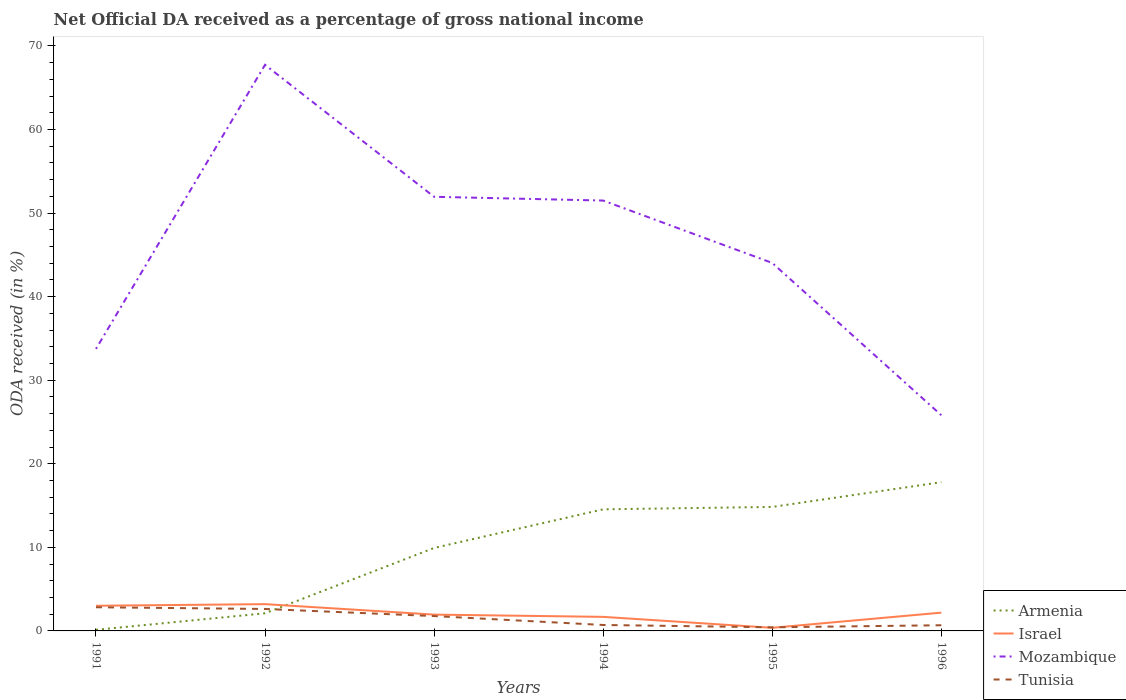Is the number of lines equal to the number of legend labels?
Keep it short and to the point. Yes. Across all years, what is the maximum net official DA received in Tunisia?
Your answer should be compact. 0.43. What is the total net official DA received in Armenia in the graph?
Your answer should be very brief. -17.66. What is the difference between the highest and the second highest net official DA received in Mozambique?
Offer a terse response. 41.92. Is the net official DA received in Israel strictly greater than the net official DA received in Mozambique over the years?
Provide a succinct answer. Yes. How many lines are there?
Ensure brevity in your answer.  4. Are the values on the major ticks of Y-axis written in scientific E-notation?
Your response must be concise. No. Where does the legend appear in the graph?
Provide a short and direct response. Bottom right. How many legend labels are there?
Your response must be concise. 4. How are the legend labels stacked?
Offer a terse response. Vertical. What is the title of the graph?
Your answer should be very brief. Net Official DA received as a percentage of gross national income. What is the label or title of the X-axis?
Your answer should be very brief. Years. What is the label or title of the Y-axis?
Provide a short and direct response. ODA received (in %). What is the ODA received (in %) in Armenia in 1991?
Make the answer very short. 0.13. What is the ODA received (in %) of Israel in 1991?
Offer a very short reply. 3.01. What is the ODA received (in %) of Mozambique in 1991?
Your answer should be very brief. 33.75. What is the ODA received (in %) in Tunisia in 1991?
Offer a terse response. 2.83. What is the ODA received (in %) of Armenia in 1992?
Your answer should be very brief. 2.11. What is the ODA received (in %) of Israel in 1992?
Your response must be concise. 3.2. What is the ODA received (in %) of Mozambique in 1992?
Your answer should be very brief. 67.74. What is the ODA received (in %) of Tunisia in 1992?
Your response must be concise. 2.63. What is the ODA received (in %) of Armenia in 1993?
Make the answer very short. 9.93. What is the ODA received (in %) of Israel in 1993?
Ensure brevity in your answer.  1.95. What is the ODA received (in %) of Mozambique in 1993?
Offer a terse response. 51.95. What is the ODA received (in %) in Tunisia in 1993?
Make the answer very short. 1.78. What is the ODA received (in %) of Armenia in 1994?
Give a very brief answer. 14.55. What is the ODA received (in %) of Israel in 1994?
Give a very brief answer. 1.68. What is the ODA received (in %) of Mozambique in 1994?
Offer a very short reply. 51.49. What is the ODA received (in %) of Tunisia in 1994?
Offer a very short reply. 0.71. What is the ODA received (in %) of Armenia in 1995?
Ensure brevity in your answer.  14.84. What is the ODA received (in %) of Israel in 1995?
Your answer should be very brief. 0.37. What is the ODA received (in %) of Mozambique in 1995?
Your response must be concise. 44.03. What is the ODA received (in %) in Tunisia in 1995?
Make the answer very short. 0.43. What is the ODA received (in %) in Armenia in 1996?
Provide a short and direct response. 17.8. What is the ODA received (in %) of Israel in 1996?
Offer a very short reply. 2.19. What is the ODA received (in %) in Mozambique in 1996?
Ensure brevity in your answer.  25.81. What is the ODA received (in %) of Tunisia in 1996?
Give a very brief answer. 0.68. Across all years, what is the maximum ODA received (in %) of Armenia?
Keep it short and to the point. 17.8. Across all years, what is the maximum ODA received (in %) of Israel?
Give a very brief answer. 3.2. Across all years, what is the maximum ODA received (in %) of Mozambique?
Your answer should be compact. 67.74. Across all years, what is the maximum ODA received (in %) in Tunisia?
Offer a terse response. 2.83. Across all years, what is the minimum ODA received (in %) of Armenia?
Give a very brief answer. 0.13. Across all years, what is the minimum ODA received (in %) in Israel?
Make the answer very short. 0.37. Across all years, what is the minimum ODA received (in %) in Mozambique?
Offer a very short reply. 25.81. Across all years, what is the minimum ODA received (in %) in Tunisia?
Your answer should be very brief. 0.43. What is the total ODA received (in %) of Armenia in the graph?
Your response must be concise. 59.35. What is the total ODA received (in %) in Israel in the graph?
Provide a succinct answer. 12.41. What is the total ODA received (in %) of Mozambique in the graph?
Make the answer very short. 274.76. What is the total ODA received (in %) of Tunisia in the graph?
Your answer should be compact. 9.06. What is the difference between the ODA received (in %) of Armenia in 1991 and that in 1992?
Make the answer very short. -1.98. What is the difference between the ODA received (in %) in Israel in 1991 and that in 1992?
Your answer should be compact. -0.19. What is the difference between the ODA received (in %) in Mozambique in 1991 and that in 1992?
Your response must be concise. -33.99. What is the difference between the ODA received (in %) in Tunisia in 1991 and that in 1992?
Provide a succinct answer. 0.2. What is the difference between the ODA received (in %) of Armenia in 1991 and that in 1993?
Your answer should be very brief. -9.8. What is the difference between the ODA received (in %) of Israel in 1991 and that in 1993?
Your answer should be compact. 1.06. What is the difference between the ODA received (in %) in Mozambique in 1991 and that in 1993?
Your answer should be very brief. -18.2. What is the difference between the ODA received (in %) in Tunisia in 1991 and that in 1993?
Your response must be concise. 1.05. What is the difference between the ODA received (in %) of Armenia in 1991 and that in 1994?
Your response must be concise. -14.42. What is the difference between the ODA received (in %) of Israel in 1991 and that in 1994?
Ensure brevity in your answer.  1.33. What is the difference between the ODA received (in %) of Mozambique in 1991 and that in 1994?
Keep it short and to the point. -17.75. What is the difference between the ODA received (in %) in Tunisia in 1991 and that in 1994?
Your response must be concise. 2.12. What is the difference between the ODA received (in %) in Armenia in 1991 and that in 1995?
Ensure brevity in your answer.  -14.71. What is the difference between the ODA received (in %) of Israel in 1991 and that in 1995?
Ensure brevity in your answer.  2.64. What is the difference between the ODA received (in %) in Mozambique in 1991 and that in 1995?
Provide a short and direct response. -10.28. What is the difference between the ODA received (in %) of Tunisia in 1991 and that in 1995?
Give a very brief answer. 2.4. What is the difference between the ODA received (in %) of Armenia in 1991 and that in 1996?
Ensure brevity in your answer.  -17.66. What is the difference between the ODA received (in %) in Israel in 1991 and that in 1996?
Offer a very short reply. 0.82. What is the difference between the ODA received (in %) of Mozambique in 1991 and that in 1996?
Provide a succinct answer. 7.93. What is the difference between the ODA received (in %) in Tunisia in 1991 and that in 1996?
Keep it short and to the point. 2.15. What is the difference between the ODA received (in %) of Armenia in 1992 and that in 1993?
Give a very brief answer. -7.82. What is the difference between the ODA received (in %) in Israel in 1992 and that in 1993?
Your answer should be very brief. 1.25. What is the difference between the ODA received (in %) in Mozambique in 1992 and that in 1993?
Your response must be concise. 15.79. What is the difference between the ODA received (in %) in Tunisia in 1992 and that in 1993?
Your answer should be very brief. 0.85. What is the difference between the ODA received (in %) in Armenia in 1992 and that in 1994?
Your response must be concise. -12.44. What is the difference between the ODA received (in %) in Israel in 1992 and that in 1994?
Make the answer very short. 1.52. What is the difference between the ODA received (in %) in Mozambique in 1992 and that in 1994?
Your answer should be very brief. 16.24. What is the difference between the ODA received (in %) of Tunisia in 1992 and that in 1994?
Ensure brevity in your answer.  1.92. What is the difference between the ODA received (in %) in Armenia in 1992 and that in 1995?
Your answer should be very brief. -12.73. What is the difference between the ODA received (in %) of Israel in 1992 and that in 1995?
Your answer should be very brief. 2.83. What is the difference between the ODA received (in %) of Mozambique in 1992 and that in 1995?
Keep it short and to the point. 23.7. What is the difference between the ODA received (in %) of Tunisia in 1992 and that in 1995?
Keep it short and to the point. 2.19. What is the difference between the ODA received (in %) of Armenia in 1992 and that in 1996?
Keep it short and to the point. -15.69. What is the difference between the ODA received (in %) of Israel in 1992 and that in 1996?
Make the answer very short. 1.02. What is the difference between the ODA received (in %) of Mozambique in 1992 and that in 1996?
Offer a very short reply. 41.92. What is the difference between the ODA received (in %) in Tunisia in 1992 and that in 1996?
Your answer should be very brief. 1.95. What is the difference between the ODA received (in %) of Armenia in 1993 and that in 1994?
Keep it short and to the point. -4.62. What is the difference between the ODA received (in %) of Israel in 1993 and that in 1994?
Provide a short and direct response. 0.27. What is the difference between the ODA received (in %) of Mozambique in 1993 and that in 1994?
Give a very brief answer. 0.45. What is the difference between the ODA received (in %) in Tunisia in 1993 and that in 1994?
Offer a terse response. 1.07. What is the difference between the ODA received (in %) of Armenia in 1993 and that in 1995?
Provide a succinct answer. -4.91. What is the difference between the ODA received (in %) of Israel in 1993 and that in 1995?
Your response must be concise. 1.58. What is the difference between the ODA received (in %) in Mozambique in 1993 and that in 1995?
Offer a very short reply. 7.91. What is the difference between the ODA received (in %) in Tunisia in 1993 and that in 1995?
Offer a very short reply. 1.34. What is the difference between the ODA received (in %) in Armenia in 1993 and that in 1996?
Keep it short and to the point. -7.87. What is the difference between the ODA received (in %) of Israel in 1993 and that in 1996?
Provide a succinct answer. -0.24. What is the difference between the ODA received (in %) in Mozambique in 1993 and that in 1996?
Your answer should be compact. 26.13. What is the difference between the ODA received (in %) in Tunisia in 1993 and that in 1996?
Offer a terse response. 1.1. What is the difference between the ODA received (in %) in Armenia in 1994 and that in 1995?
Offer a terse response. -0.29. What is the difference between the ODA received (in %) of Israel in 1994 and that in 1995?
Offer a very short reply. 1.31. What is the difference between the ODA received (in %) of Mozambique in 1994 and that in 1995?
Keep it short and to the point. 7.46. What is the difference between the ODA received (in %) of Tunisia in 1994 and that in 1995?
Your answer should be very brief. 0.28. What is the difference between the ODA received (in %) in Armenia in 1994 and that in 1996?
Offer a very short reply. -3.25. What is the difference between the ODA received (in %) of Israel in 1994 and that in 1996?
Your response must be concise. -0.51. What is the difference between the ODA received (in %) in Mozambique in 1994 and that in 1996?
Provide a short and direct response. 25.68. What is the difference between the ODA received (in %) in Tunisia in 1994 and that in 1996?
Your answer should be very brief. 0.03. What is the difference between the ODA received (in %) in Armenia in 1995 and that in 1996?
Your answer should be compact. -2.96. What is the difference between the ODA received (in %) in Israel in 1995 and that in 1996?
Make the answer very short. -1.81. What is the difference between the ODA received (in %) in Mozambique in 1995 and that in 1996?
Provide a short and direct response. 18.22. What is the difference between the ODA received (in %) of Tunisia in 1995 and that in 1996?
Provide a short and direct response. -0.25. What is the difference between the ODA received (in %) of Armenia in 1991 and the ODA received (in %) of Israel in 1992?
Offer a very short reply. -3.07. What is the difference between the ODA received (in %) of Armenia in 1991 and the ODA received (in %) of Mozambique in 1992?
Offer a terse response. -67.6. What is the difference between the ODA received (in %) in Armenia in 1991 and the ODA received (in %) in Tunisia in 1992?
Make the answer very short. -2.5. What is the difference between the ODA received (in %) in Israel in 1991 and the ODA received (in %) in Mozambique in 1992?
Offer a terse response. -64.72. What is the difference between the ODA received (in %) of Israel in 1991 and the ODA received (in %) of Tunisia in 1992?
Your response must be concise. 0.39. What is the difference between the ODA received (in %) in Mozambique in 1991 and the ODA received (in %) in Tunisia in 1992?
Give a very brief answer. 31.12. What is the difference between the ODA received (in %) in Armenia in 1991 and the ODA received (in %) in Israel in 1993?
Ensure brevity in your answer.  -1.82. What is the difference between the ODA received (in %) of Armenia in 1991 and the ODA received (in %) of Mozambique in 1993?
Make the answer very short. -51.81. What is the difference between the ODA received (in %) in Armenia in 1991 and the ODA received (in %) in Tunisia in 1993?
Your response must be concise. -1.65. What is the difference between the ODA received (in %) of Israel in 1991 and the ODA received (in %) of Mozambique in 1993?
Offer a very short reply. -48.93. What is the difference between the ODA received (in %) in Israel in 1991 and the ODA received (in %) in Tunisia in 1993?
Make the answer very short. 1.24. What is the difference between the ODA received (in %) of Mozambique in 1991 and the ODA received (in %) of Tunisia in 1993?
Keep it short and to the point. 31.97. What is the difference between the ODA received (in %) of Armenia in 1991 and the ODA received (in %) of Israel in 1994?
Offer a terse response. -1.55. What is the difference between the ODA received (in %) of Armenia in 1991 and the ODA received (in %) of Mozambique in 1994?
Make the answer very short. -51.36. What is the difference between the ODA received (in %) of Armenia in 1991 and the ODA received (in %) of Tunisia in 1994?
Offer a terse response. -0.58. What is the difference between the ODA received (in %) of Israel in 1991 and the ODA received (in %) of Mozambique in 1994?
Your answer should be compact. -48.48. What is the difference between the ODA received (in %) in Israel in 1991 and the ODA received (in %) in Tunisia in 1994?
Provide a short and direct response. 2.3. What is the difference between the ODA received (in %) in Mozambique in 1991 and the ODA received (in %) in Tunisia in 1994?
Your answer should be compact. 33.04. What is the difference between the ODA received (in %) of Armenia in 1991 and the ODA received (in %) of Israel in 1995?
Ensure brevity in your answer.  -0.24. What is the difference between the ODA received (in %) of Armenia in 1991 and the ODA received (in %) of Mozambique in 1995?
Provide a short and direct response. -43.9. What is the difference between the ODA received (in %) of Armenia in 1991 and the ODA received (in %) of Tunisia in 1995?
Your answer should be compact. -0.3. What is the difference between the ODA received (in %) of Israel in 1991 and the ODA received (in %) of Mozambique in 1995?
Offer a terse response. -41.02. What is the difference between the ODA received (in %) of Israel in 1991 and the ODA received (in %) of Tunisia in 1995?
Ensure brevity in your answer.  2.58. What is the difference between the ODA received (in %) of Mozambique in 1991 and the ODA received (in %) of Tunisia in 1995?
Make the answer very short. 33.31. What is the difference between the ODA received (in %) in Armenia in 1991 and the ODA received (in %) in Israel in 1996?
Provide a succinct answer. -2.06. What is the difference between the ODA received (in %) in Armenia in 1991 and the ODA received (in %) in Mozambique in 1996?
Offer a terse response. -25.68. What is the difference between the ODA received (in %) of Armenia in 1991 and the ODA received (in %) of Tunisia in 1996?
Your response must be concise. -0.55. What is the difference between the ODA received (in %) of Israel in 1991 and the ODA received (in %) of Mozambique in 1996?
Keep it short and to the point. -22.8. What is the difference between the ODA received (in %) in Israel in 1991 and the ODA received (in %) in Tunisia in 1996?
Give a very brief answer. 2.33. What is the difference between the ODA received (in %) in Mozambique in 1991 and the ODA received (in %) in Tunisia in 1996?
Provide a short and direct response. 33.07. What is the difference between the ODA received (in %) of Armenia in 1992 and the ODA received (in %) of Israel in 1993?
Make the answer very short. 0.16. What is the difference between the ODA received (in %) of Armenia in 1992 and the ODA received (in %) of Mozambique in 1993?
Give a very brief answer. -49.83. What is the difference between the ODA received (in %) in Armenia in 1992 and the ODA received (in %) in Tunisia in 1993?
Keep it short and to the point. 0.33. What is the difference between the ODA received (in %) of Israel in 1992 and the ODA received (in %) of Mozambique in 1993?
Keep it short and to the point. -48.74. What is the difference between the ODA received (in %) of Israel in 1992 and the ODA received (in %) of Tunisia in 1993?
Give a very brief answer. 1.43. What is the difference between the ODA received (in %) of Mozambique in 1992 and the ODA received (in %) of Tunisia in 1993?
Your answer should be compact. 65.96. What is the difference between the ODA received (in %) in Armenia in 1992 and the ODA received (in %) in Israel in 1994?
Your response must be concise. 0.43. What is the difference between the ODA received (in %) of Armenia in 1992 and the ODA received (in %) of Mozambique in 1994?
Give a very brief answer. -49.38. What is the difference between the ODA received (in %) of Armenia in 1992 and the ODA received (in %) of Tunisia in 1994?
Give a very brief answer. 1.4. What is the difference between the ODA received (in %) of Israel in 1992 and the ODA received (in %) of Mozambique in 1994?
Your answer should be compact. -48.29. What is the difference between the ODA received (in %) in Israel in 1992 and the ODA received (in %) in Tunisia in 1994?
Provide a short and direct response. 2.49. What is the difference between the ODA received (in %) in Mozambique in 1992 and the ODA received (in %) in Tunisia in 1994?
Your response must be concise. 67.02. What is the difference between the ODA received (in %) in Armenia in 1992 and the ODA received (in %) in Israel in 1995?
Your response must be concise. 1.74. What is the difference between the ODA received (in %) in Armenia in 1992 and the ODA received (in %) in Mozambique in 1995?
Your response must be concise. -41.92. What is the difference between the ODA received (in %) in Armenia in 1992 and the ODA received (in %) in Tunisia in 1995?
Offer a very short reply. 1.68. What is the difference between the ODA received (in %) of Israel in 1992 and the ODA received (in %) of Mozambique in 1995?
Your response must be concise. -40.83. What is the difference between the ODA received (in %) in Israel in 1992 and the ODA received (in %) in Tunisia in 1995?
Ensure brevity in your answer.  2.77. What is the difference between the ODA received (in %) of Mozambique in 1992 and the ODA received (in %) of Tunisia in 1995?
Keep it short and to the point. 67.3. What is the difference between the ODA received (in %) of Armenia in 1992 and the ODA received (in %) of Israel in 1996?
Provide a succinct answer. -0.08. What is the difference between the ODA received (in %) of Armenia in 1992 and the ODA received (in %) of Mozambique in 1996?
Ensure brevity in your answer.  -23.7. What is the difference between the ODA received (in %) of Armenia in 1992 and the ODA received (in %) of Tunisia in 1996?
Keep it short and to the point. 1.43. What is the difference between the ODA received (in %) in Israel in 1992 and the ODA received (in %) in Mozambique in 1996?
Your answer should be very brief. -22.61. What is the difference between the ODA received (in %) of Israel in 1992 and the ODA received (in %) of Tunisia in 1996?
Provide a succinct answer. 2.53. What is the difference between the ODA received (in %) of Mozambique in 1992 and the ODA received (in %) of Tunisia in 1996?
Provide a succinct answer. 67.06. What is the difference between the ODA received (in %) of Armenia in 1993 and the ODA received (in %) of Israel in 1994?
Your answer should be compact. 8.25. What is the difference between the ODA received (in %) in Armenia in 1993 and the ODA received (in %) in Mozambique in 1994?
Keep it short and to the point. -41.57. What is the difference between the ODA received (in %) in Armenia in 1993 and the ODA received (in %) in Tunisia in 1994?
Your answer should be compact. 9.22. What is the difference between the ODA received (in %) of Israel in 1993 and the ODA received (in %) of Mozambique in 1994?
Your answer should be very brief. -49.54. What is the difference between the ODA received (in %) of Israel in 1993 and the ODA received (in %) of Tunisia in 1994?
Provide a short and direct response. 1.24. What is the difference between the ODA received (in %) in Mozambique in 1993 and the ODA received (in %) in Tunisia in 1994?
Ensure brevity in your answer.  51.23. What is the difference between the ODA received (in %) of Armenia in 1993 and the ODA received (in %) of Israel in 1995?
Make the answer very short. 9.55. What is the difference between the ODA received (in %) in Armenia in 1993 and the ODA received (in %) in Mozambique in 1995?
Provide a succinct answer. -34.1. What is the difference between the ODA received (in %) of Armenia in 1993 and the ODA received (in %) of Tunisia in 1995?
Your response must be concise. 9.49. What is the difference between the ODA received (in %) of Israel in 1993 and the ODA received (in %) of Mozambique in 1995?
Your answer should be very brief. -42.08. What is the difference between the ODA received (in %) of Israel in 1993 and the ODA received (in %) of Tunisia in 1995?
Give a very brief answer. 1.52. What is the difference between the ODA received (in %) in Mozambique in 1993 and the ODA received (in %) in Tunisia in 1995?
Provide a short and direct response. 51.51. What is the difference between the ODA received (in %) of Armenia in 1993 and the ODA received (in %) of Israel in 1996?
Make the answer very short. 7.74. What is the difference between the ODA received (in %) in Armenia in 1993 and the ODA received (in %) in Mozambique in 1996?
Give a very brief answer. -15.88. What is the difference between the ODA received (in %) of Armenia in 1993 and the ODA received (in %) of Tunisia in 1996?
Your answer should be very brief. 9.25. What is the difference between the ODA received (in %) in Israel in 1993 and the ODA received (in %) in Mozambique in 1996?
Your answer should be compact. -23.86. What is the difference between the ODA received (in %) of Israel in 1993 and the ODA received (in %) of Tunisia in 1996?
Make the answer very short. 1.27. What is the difference between the ODA received (in %) of Mozambique in 1993 and the ODA received (in %) of Tunisia in 1996?
Ensure brevity in your answer.  51.27. What is the difference between the ODA received (in %) of Armenia in 1994 and the ODA received (in %) of Israel in 1995?
Offer a terse response. 14.18. What is the difference between the ODA received (in %) of Armenia in 1994 and the ODA received (in %) of Mozambique in 1995?
Your answer should be compact. -29.48. What is the difference between the ODA received (in %) in Armenia in 1994 and the ODA received (in %) in Tunisia in 1995?
Your answer should be compact. 14.12. What is the difference between the ODA received (in %) in Israel in 1994 and the ODA received (in %) in Mozambique in 1995?
Your response must be concise. -42.35. What is the difference between the ODA received (in %) of Israel in 1994 and the ODA received (in %) of Tunisia in 1995?
Offer a very short reply. 1.25. What is the difference between the ODA received (in %) in Mozambique in 1994 and the ODA received (in %) in Tunisia in 1995?
Provide a succinct answer. 51.06. What is the difference between the ODA received (in %) of Armenia in 1994 and the ODA received (in %) of Israel in 1996?
Give a very brief answer. 12.36. What is the difference between the ODA received (in %) in Armenia in 1994 and the ODA received (in %) in Mozambique in 1996?
Your answer should be compact. -11.26. What is the difference between the ODA received (in %) of Armenia in 1994 and the ODA received (in %) of Tunisia in 1996?
Provide a succinct answer. 13.87. What is the difference between the ODA received (in %) in Israel in 1994 and the ODA received (in %) in Mozambique in 1996?
Offer a very short reply. -24.13. What is the difference between the ODA received (in %) in Mozambique in 1994 and the ODA received (in %) in Tunisia in 1996?
Your answer should be compact. 50.82. What is the difference between the ODA received (in %) of Armenia in 1995 and the ODA received (in %) of Israel in 1996?
Ensure brevity in your answer.  12.65. What is the difference between the ODA received (in %) of Armenia in 1995 and the ODA received (in %) of Mozambique in 1996?
Make the answer very short. -10.97. What is the difference between the ODA received (in %) in Armenia in 1995 and the ODA received (in %) in Tunisia in 1996?
Provide a succinct answer. 14.16. What is the difference between the ODA received (in %) in Israel in 1995 and the ODA received (in %) in Mozambique in 1996?
Ensure brevity in your answer.  -25.44. What is the difference between the ODA received (in %) in Israel in 1995 and the ODA received (in %) in Tunisia in 1996?
Keep it short and to the point. -0.31. What is the difference between the ODA received (in %) in Mozambique in 1995 and the ODA received (in %) in Tunisia in 1996?
Offer a very short reply. 43.35. What is the average ODA received (in %) in Armenia per year?
Provide a succinct answer. 9.89. What is the average ODA received (in %) of Israel per year?
Your answer should be very brief. 2.07. What is the average ODA received (in %) in Mozambique per year?
Offer a terse response. 45.79. What is the average ODA received (in %) in Tunisia per year?
Offer a very short reply. 1.51. In the year 1991, what is the difference between the ODA received (in %) in Armenia and ODA received (in %) in Israel?
Your answer should be compact. -2.88. In the year 1991, what is the difference between the ODA received (in %) in Armenia and ODA received (in %) in Mozambique?
Offer a very short reply. -33.62. In the year 1991, what is the difference between the ODA received (in %) in Armenia and ODA received (in %) in Tunisia?
Provide a short and direct response. -2.7. In the year 1991, what is the difference between the ODA received (in %) of Israel and ODA received (in %) of Mozambique?
Give a very brief answer. -30.73. In the year 1991, what is the difference between the ODA received (in %) of Israel and ODA received (in %) of Tunisia?
Offer a terse response. 0.18. In the year 1991, what is the difference between the ODA received (in %) in Mozambique and ODA received (in %) in Tunisia?
Ensure brevity in your answer.  30.92. In the year 1992, what is the difference between the ODA received (in %) of Armenia and ODA received (in %) of Israel?
Make the answer very short. -1.09. In the year 1992, what is the difference between the ODA received (in %) of Armenia and ODA received (in %) of Mozambique?
Make the answer very short. -65.62. In the year 1992, what is the difference between the ODA received (in %) in Armenia and ODA received (in %) in Tunisia?
Offer a terse response. -0.52. In the year 1992, what is the difference between the ODA received (in %) of Israel and ODA received (in %) of Mozambique?
Your answer should be compact. -64.53. In the year 1992, what is the difference between the ODA received (in %) in Israel and ODA received (in %) in Tunisia?
Your response must be concise. 0.58. In the year 1992, what is the difference between the ODA received (in %) of Mozambique and ODA received (in %) of Tunisia?
Make the answer very short. 65.11. In the year 1993, what is the difference between the ODA received (in %) in Armenia and ODA received (in %) in Israel?
Your answer should be very brief. 7.98. In the year 1993, what is the difference between the ODA received (in %) of Armenia and ODA received (in %) of Mozambique?
Provide a succinct answer. -42.02. In the year 1993, what is the difference between the ODA received (in %) in Armenia and ODA received (in %) in Tunisia?
Ensure brevity in your answer.  8.15. In the year 1993, what is the difference between the ODA received (in %) in Israel and ODA received (in %) in Mozambique?
Your response must be concise. -49.99. In the year 1993, what is the difference between the ODA received (in %) of Israel and ODA received (in %) of Tunisia?
Provide a short and direct response. 0.17. In the year 1993, what is the difference between the ODA received (in %) in Mozambique and ODA received (in %) in Tunisia?
Your response must be concise. 50.17. In the year 1994, what is the difference between the ODA received (in %) in Armenia and ODA received (in %) in Israel?
Provide a succinct answer. 12.87. In the year 1994, what is the difference between the ODA received (in %) in Armenia and ODA received (in %) in Mozambique?
Provide a short and direct response. -36.95. In the year 1994, what is the difference between the ODA received (in %) in Armenia and ODA received (in %) in Tunisia?
Give a very brief answer. 13.84. In the year 1994, what is the difference between the ODA received (in %) of Israel and ODA received (in %) of Mozambique?
Your response must be concise. -49.81. In the year 1994, what is the difference between the ODA received (in %) in Israel and ODA received (in %) in Tunisia?
Provide a short and direct response. 0.97. In the year 1994, what is the difference between the ODA received (in %) of Mozambique and ODA received (in %) of Tunisia?
Give a very brief answer. 50.78. In the year 1995, what is the difference between the ODA received (in %) of Armenia and ODA received (in %) of Israel?
Provide a short and direct response. 14.46. In the year 1995, what is the difference between the ODA received (in %) in Armenia and ODA received (in %) in Mozambique?
Your answer should be compact. -29.19. In the year 1995, what is the difference between the ODA received (in %) of Armenia and ODA received (in %) of Tunisia?
Your answer should be compact. 14.4. In the year 1995, what is the difference between the ODA received (in %) of Israel and ODA received (in %) of Mozambique?
Offer a very short reply. -43.66. In the year 1995, what is the difference between the ODA received (in %) of Israel and ODA received (in %) of Tunisia?
Provide a succinct answer. -0.06. In the year 1995, what is the difference between the ODA received (in %) of Mozambique and ODA received (in %) of Tunisia?
Keep it short and to the point. 43.6. In the year 1996, what is the difference between the ODA received (in %) of Armenia and ODA received (in %) of Israel?
Ensure brevity in your answer.  15.61. In the year 1996, what is the difference between the ODA received (in %) of Armenia and ODA received (in %) of Mozambique?
Keep it short and to the point. -8.02. In the year 1996, what is the difference between the ODA received (in %) in Armenia and ODA received (in %) in Tunisia?
Make the answer very short. 17.12. In the year 1996, what is the difference between the ODA received (in %) of Israel and ODA received (in %) of Mozambique?
Provide a succinct answer. -23.62. In the year 1996, what is the difference between the ODA received (in %) in Israel and ODA received (in %) in Tunisia?
Ensure brevity in your answer.  1.51. In the year 1996, what is the difference between the ODA received (in %) of Mozambique and ODA received (in %) of Tunisia?
Your answer should be compact. 25.13. What is the ratio of the ODA received (in %) of Armenia in 1991 to that in 1992?
Keep it short and to the point. 0.06. What is the ratio of the ODA received (in %) in Israel in 1991 to that in 1992?
Ensure brevity in your answer.  0.94. What is the ratio of the ODA received (in %) in Mozambique in 1991 to that in 1992?
Ensure brevity in your answer.  0.5. What is the ratio of the ODA received (in %) in Tunisia in 1991 to that in 1992?
Offer a very short reply. 1.08. What is the ratio of the ODA received (in %) in Armenia in 1991 to that in 1993?
Make the answer very short. 0.01. What is the ratio of the ODA received (in %) of Israel in 1991 to that in 1993?
Make the answer very short. 1.54. What is the ratio of the ODA received (in %) of Mozambique in 1991 to that in 1993?
Keep it short and to the point. 0.65. What is the ratio of the ODA received (in %) of Tunisia in 1991 to that in 1993?
Keep it short and to the point. 1.59. What is the ratio of the ODA received (in %) in Armenia in 1991 to that in 1994?
Your response must be concise. 0.01. What is the ratio of the ODA received (in %) in Israel in 1991 to that in 1994?
Give a very brief answer. 1.79. What is the ratio of the ODA received (in %) of Mozambique in 1991 to that in 1994?
Offer a very short reply. 0.66. What is the ratio of the ODA received (in %) in Tunisia in 1991 to that in 1994?
Your response must be concise. 3.98. What is the ratio of the ODA received (in %) in Armenia in 1991 to that in 1995?
Your answer should be very brief. 0.01. What is the ratio of the ODA received (in %) in Israel in 1991 to that in 1995?
Offer a terse response. 8.08. What is the ratio of the ODA received (in %) of Mozambique in 1991 to that in 1995?
Your answer should be very brief. 0.77. What is the ratio of the ODA received (in %) of Tunisia in 1991 to that in 1995?
Your response must be concise. 6.54. What is the ratio of the ODA received (in %) in Armenia in 1991 to that in 1996?
Provide a short and direct response. 0.01. What is the ratio of the ODA received (in %) of Israel in 1991 to that in 1996?
Offer a very short reply. 1.38. What is the ratio of the ODA received (in %) of Mozambique in 1991 to that in 1996?
Your response must be concise. 1.31. What is the ratio of the ODA received (in %) of Tunisia in 1991 to that in 1996?
Give a very brief answer. 4.17. What is the ratio of the ODA received (in %) of Armenia in 1992 to that in 1993?
Ensure brevity in your answer.  0.21. What is the ratio of the ODA received (in %) of Israel in 1992 to that in 1993?
Your response must be concise. 1.64. What is the ratio of the ODA received (in %) in Mozambique in 1992 to that in 1993?
Make the answer very short. 1.3. What is the ratio of the ODA received (in %) in Tunisia in 1992 to that in 1993?
Ensure brevity in your answer.  1.48. What is the ratio of the ODA received (in %) of Armenia in 1992 to that in 1994?
Ensure brevity in your answer.  0.15. What is the ratio of the ODA received (in %) of Israel in 1992 to that in 1994?
Offer a terse response. 1.91. What is the ratio of the ODA received (in %) of Mozambique in 1992 to that in 1994?
Make the answer very short. 1.32. What is the ratio of the ODA received (in %) in Tunisia in 1992 to that in 1994?
Offer a very short reply. 3.7. What is the ratio of the ODA received (in %) in Armenia in 1992 to that in 1995?
Provide a succinct answer. 0.14. What is the ratio of the ODA received (in %) of Israel in 1992 to that in 1995?
Provide a short and direct response. 8.6. What is the ratio of the ODA received (in %) in Mozambique in 1992 to that in 1995?
Your answer should be very brief. 1.54. What is the ratio of the ODA received (in %) of Tunisia in 1992 to that in 1995?
Give a very brief answer. 6.06. What is the ratio of the ODA received (in %) of Armenia in 1992 to that in 1996?
Your answer should be very brief. 0.12. What is the ratio of the ODA received (in %) in Israel in 1992 to that in 1996?
Your answer should be very brief. 1.46. What is the ratio of the ODA received (in %) of Mozambique in 1992 to that in 1996?
Your answer should be compact. 2.62. What is the ratio of the ODA received (in %) in Tunisia in 1992 to that in 1996?
Give a very brief answer. 3.87. What is the ratio of the ODA received (in %) of Armenia in 1993 to that in 1994?
Make the answer very short. 0.68. What is the ratio of the ODA received (in %) of Israel in 1993 to that in 1994?
Keep it short and to the point. 1.16. What is the ratio of the ODA received (in %) in Mozambique in 1993 to that in 1994?
Provide a succinct answer. 1.01. What is the ratio of the ODA received (in %) in Tunisia in 1993 to that in 1994?
Your answer should be very brief. 2.5. What is the ratio of the ODA received (in %) in Armenia in 1993 to that in 1995?
Your answer should be very brief. 0.67. What is the ratio of the ODA received (in %) in Israel in 1993 to that in 1995?
Provide a succinct answer. 5.24. What is the ratio of the ODA received (in %) of Mozambique in 1993 to that in 1995?
Your answer should be very brief. 1.18. What is the ratio of the ODA received (in %) of Tunisia in 1993 to that in 1995?
Ensure brevity in your answer.  4.1. What is the ratio of the ODA received (in %) in Armenia in 1993 to that in 1996?
Give a very brief answer. 0.56. What is the ratio of the ODA received (in %) in Israel in 1993 to that in 1996?
Your answer should be very brief. 0.89. What is the ratio of the ODA received (in %) of Mozambique in 1993 to that in 1996?
Your answer should be compact. 2.01. What is the ratio of the ODA received (in %) of Tunisia in 1993 to that in 1996?
Provide a short and direct response. 2.62. What is the ratio of the ODA received (in %) in Armenia in 1994 to that in 1995?
Your answer should be very brief. 0.98. What is the ratio of the ODA received (in %) of Israel in 1994 to that in 1995?
Your answer should be compact. 4.51. What is the ratio of the ODA received (in %) in Mozambique in 1994 to that in 1995?
Keep it short and to the point. 1.17. What is the ratio of the ODA received (in %) of Tunisia in 1994 to that in 1995?
Your answer should be compact. 1.64. What is the ratio of the ODA received (in %) of Armenia in 1994 to that in 1996?
Ensure brevity in your answer.  0.82. What is the ratio of the ODA received (in %) of Israel in 1994 to that in 1996?
Make the answer very short. 0.77. What is the ratio of the ODA received (in %) in Mozambique in 1994 to that in 1996?
Ensure brevity in your answer.  2. What is the ratio of the ODA received (in %) in Tunisia in 1994 to that in 1996?
Provide a succinct answer. 1.05. What is the ratio of the ODA received (in %) of Armenia in 1995 to that in 1996?
Your answer should be very brief. 0.83. What is the ratio of the ODA received (in %) in Israel in 1995 to that in 1996?
Offer a terse response. 0.17. What is the ratio of the ODA received (in %) of Mozambique in 1995 to that in 1996?
Your response must be concise. 1.71. What is the ratio of the ODA received (in %) in Tunisia in 1995 to that in 1996?
Give a very brief answer. 0.64. What is the difference between the highest and the second highest ODA received (in %) of Armenia?
Your response must be concise. 2.96. What is the difference between the highest and the second highest ODA received (in %) of Israel?
Your answer should be compact. 0.19. What is the difference between the highest and the second highest ODA received (in %) in Mozambique?
Your answer should be compact. 15.79. What is the difference between the highest and the second highest ODA received (in %) in Tunisia?
Offer a very short reply. 0.2. What is the difference between the highest and the lowest ODA received (in %) of Armenia?
Your answer should be compact. 17.66. What is the difference between the highest and the lowest ODA received (in %) of Israel?
Give a very brief answer. 2.83. What is the difference between the highest and the lowest ODA received (in %) of Mozambique?
Your response must be concise. 41.92. What is the difference between the highest and the lowest ODA received (in %) in Tunisia?
Provide a short and direct response. 2.4. 